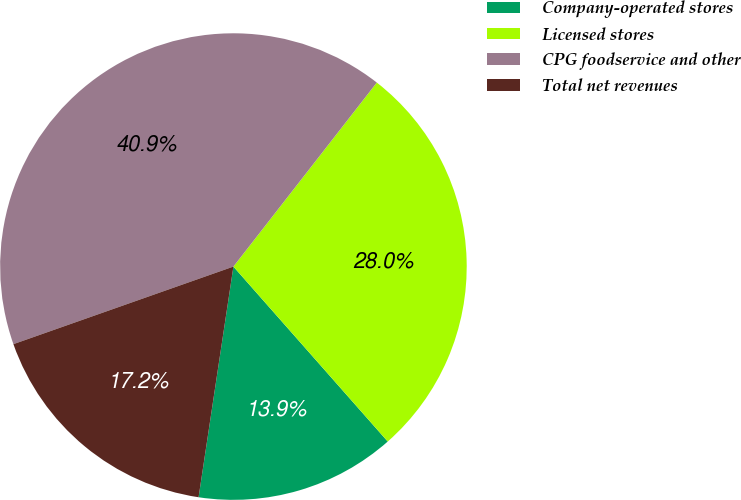<chart> <loc_0><loc_0><loc_500><loc_500><pie_chart><fcel>Company-operated stores<fcel>Licensed stores<fcel>CPG foodservice and other<fcel>Total net revenues<nl><fcel>13.89%<fcel>27.96%<fcel>40.93%<fcel>17.22%<nl></chart> 